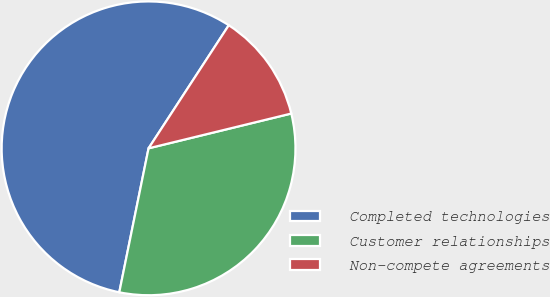<chart> <loc_0><loc_0><loc_500><loc_500><pie_chart><fcel>Completed technologies<fcel>Customer relationships<fcel>Non-compete agreements<nl><fcel>56.0%<fcel>32.0%<fcel>12.0%<nl></chart> 